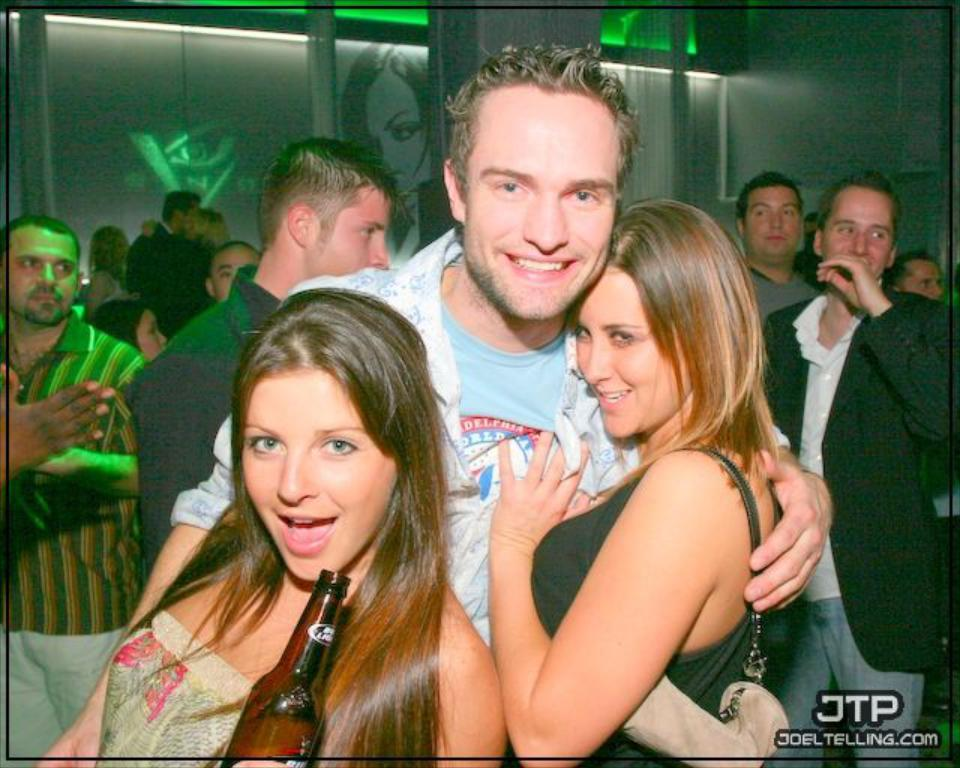What is the main subject of the image? The main subject of the image is a group of people. Can you describe what one of the individuals is doing? Yes, a girl is holding a bottle in her hand. What type of sofa can be seen in the image? There is no sofa present in the image. How does the behavior of the group of people change throughout the image? The provided facts do not give any information about the behavior of the group of people or how it changes over time. 